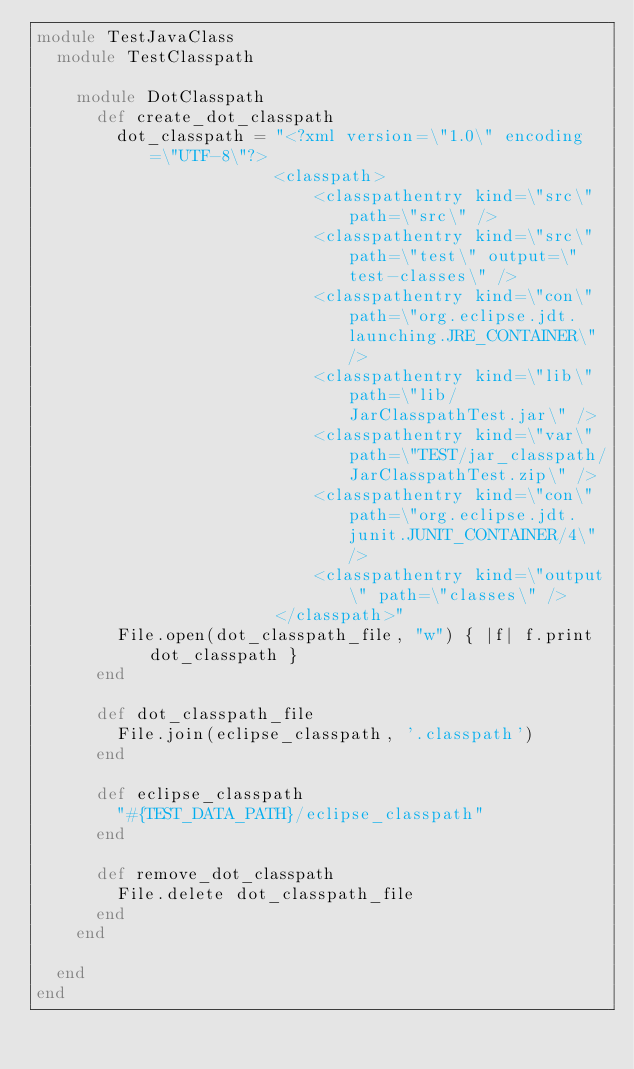<code> <loc_0><loc_0><loc_500><loc_500><_Ruby_>module TestJavaClass
  module TestClasspath
   
    module DotClasspath
      def create_dot_classpath
        dot_classpath = "<?xml version=\"1.0\" encoding=\"UTF-8\"?>
                        <classpath>
                            <classpathentry kind=\"src\" path=\"src\" />
                            <classpathentry kind=\"src\" path=\"test\" output=\"test-classes\" />
                            <classpathentry kind=\"con\" path=\"org.eclipse.jdt.launching.JRE_CONTAINER\" />
                            <classpathentry kind=\"lib\" path=\"lib/JarClasspathTest.jar\" />
                            <classpathentry kind=\"var\" path=\"TEST/jar_classpath/JarClasspathTest.zip\" />
                            <classpathentry kind=\"con\" path=\"org.eclipse.jdt.junit.JUNIT_CONTAINER/4\" />
                            <classpathentry kind=\"output\" path=\"classes\" />
                        </classpath>"
        File.open(dot_classpath_file, "w") { |f| f.print dot_classpath }
      end

      def dot_classpath_file
        File.join(eclipse_classpath, '.classpath')
      end

      def eclipse_classpath
        "#{TEST_DATA_PATH}/eclipse_classpath"
      end

      def remove_dot_classpath
        File.delete dot_classpath_file
      end
    end

  end
end</code> 